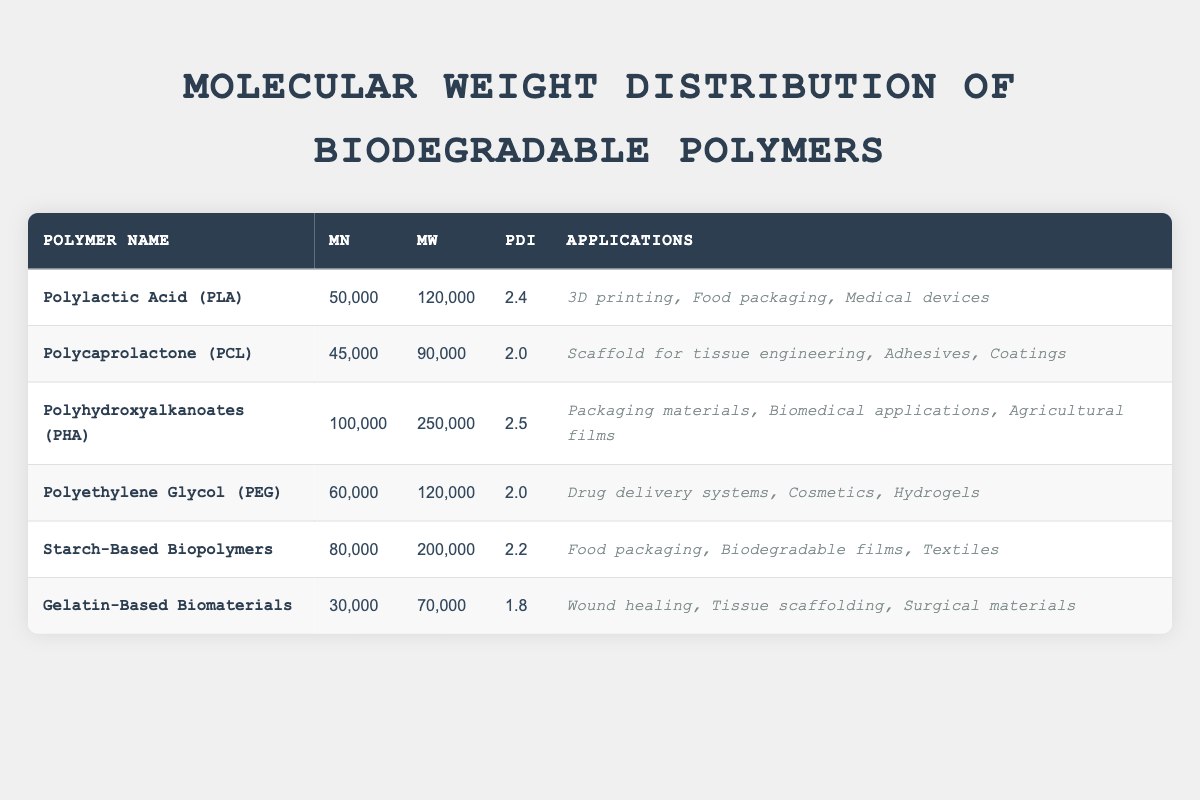What is the molecular weight (Mw) of Polycaprolactone (PCL)? The Mw value is listed in the table corresponding to PCL. It is 90,000.
Answer: 90,000 Which polymer has the highest number-average molecular weight (Mn)? Looking at the Mn values in the table, Polyhydroxyalkanoates (PHA) has the highest value at 100,000.
Answer: Polyhydroxyalkanoates (PHA) What is the PDI of Gelatin-Based Biomaterials? The PDI value is directly found in the table under Gelatin-Based Biomaterials, which is 1.8.
Answer: 1.8 Which biodegradable polymer has the greatest difference between Mw and Mn? The differences for each polymer can be calculated. For PHA, Mw is 250,000 and Mn is 100,000, giving a difference of 150,000. For PLA, the difference is 70,000. Checking each, PHA has the highest difference.
Answer: Polyhydroxyalkanoates (PHA) Is the PDI of Polyethylene Glycol (PEG) greater than 2? PEG has a PDI value of 2.0, which is equal to 2 and not greater. This means the statement is false.
Answer: No What is the total number of applications listed for Polylactic Acid (PLA) and Polycaprolactone (PCL) combined? PLA has 3 applications and PCL has 3 applications as well. Adding these together gives 3 + 3 = 6 applications.
Answer: 6 Which biodegradable polymers have a PDI less than 2.2? By reviewing the PDI values, Gelatin-Based Biomaterials (1.8) and Polycaprolactone (2.0) both have PDI values below 2.2.
Answer: Gelatin-Based Biomaterials and Polycaprolactone What is the average value of Mn for all the polymers listed in the table? Adding all the Mn values: 50,000 (PLA) + 45,000 (PCL) + 100,000 (PHA) + 60,000 (PEG) + 80,000 (Starch) + 30,000 (Gelatin) gives 365,000. Dividing by 6 gives an average of 60,833.33, rounded to 60,833.
Answer: 60,833 Which polymer has the lowest molecular weight (Mn)? The lowest Mn is listed in the table under Gelatin-Based Biomaterials, which is 30,000.
Answer: Gelatin-Based Biomaterials If we categorize the applications of PHA, what percentage of them relate to biomedical applications? PHA has 3 applications, one of which is biomedical. Thus, the percentage is (1/3) * 100 = 33.33%.
Answer: 33.33% 